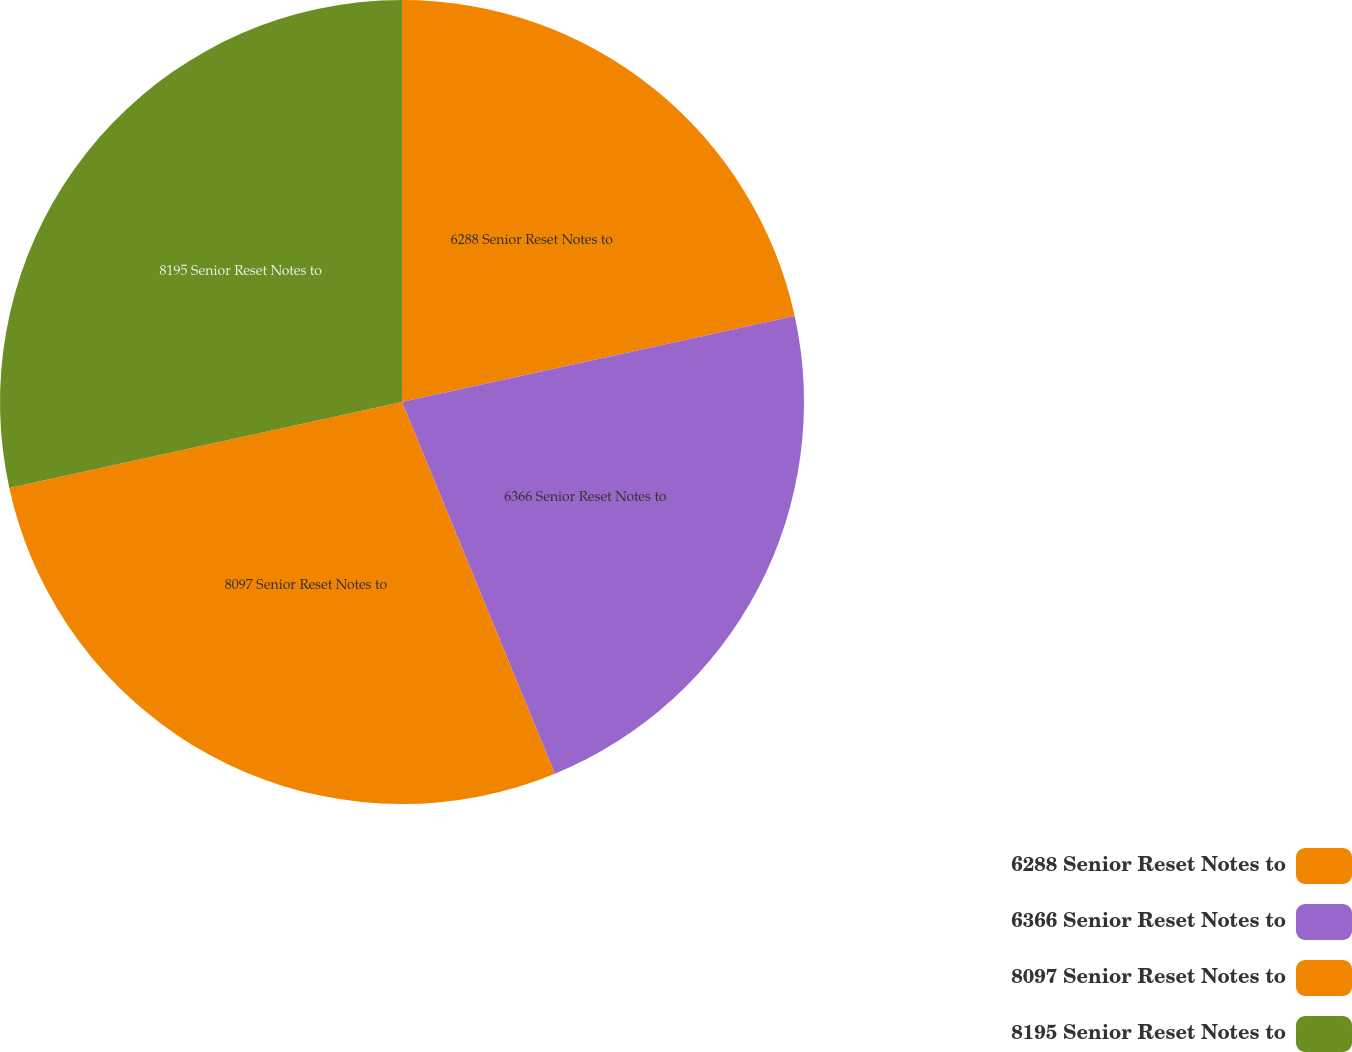<chart> <loc_0><loc_0><loc_500><loc_500><pie_chart><fcel>6288 Senior Reset Notes to<fcel>6366 Senior Reset Notes to<fcel>8097 Senior Reset Notes to<fcel>8195 Senior Reset Notes to<nl><fcel>21.57%<fcel>22.22%<fcel>27.78%<fcel>28.43%<nl></chart> 